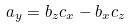Convert formula to latex. <formula><loc_0><loc_0><loc_500><loc_500>a _ { y } = b _ { z } c _ { x } - b _ { x } c _ { z }</formula> 